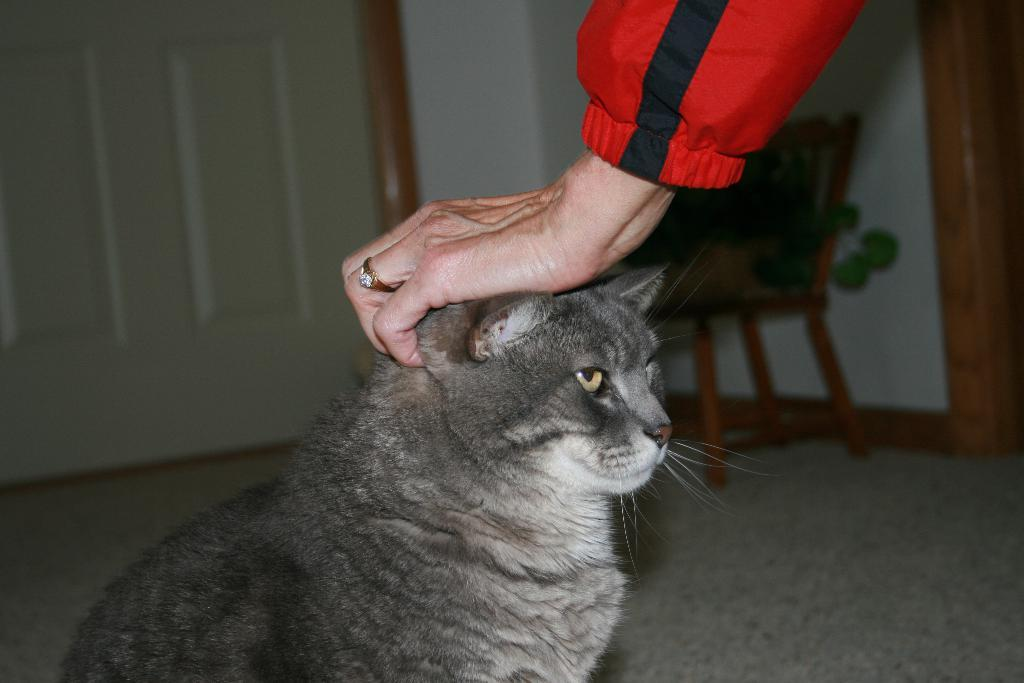What animal is present in the image? There is a cat in the image. What is the person in the image doing with the cat? A person is touching the cat. What can be seen in the background of the image? There is a door and a chair in the background of the image. What is on the chair? There is an object on the chair. How many horses are visible in the image? There are no horses present in the image. What type of cat is sitting on the bucket in the image? There is no bucket or any other type of cat present in the image. 